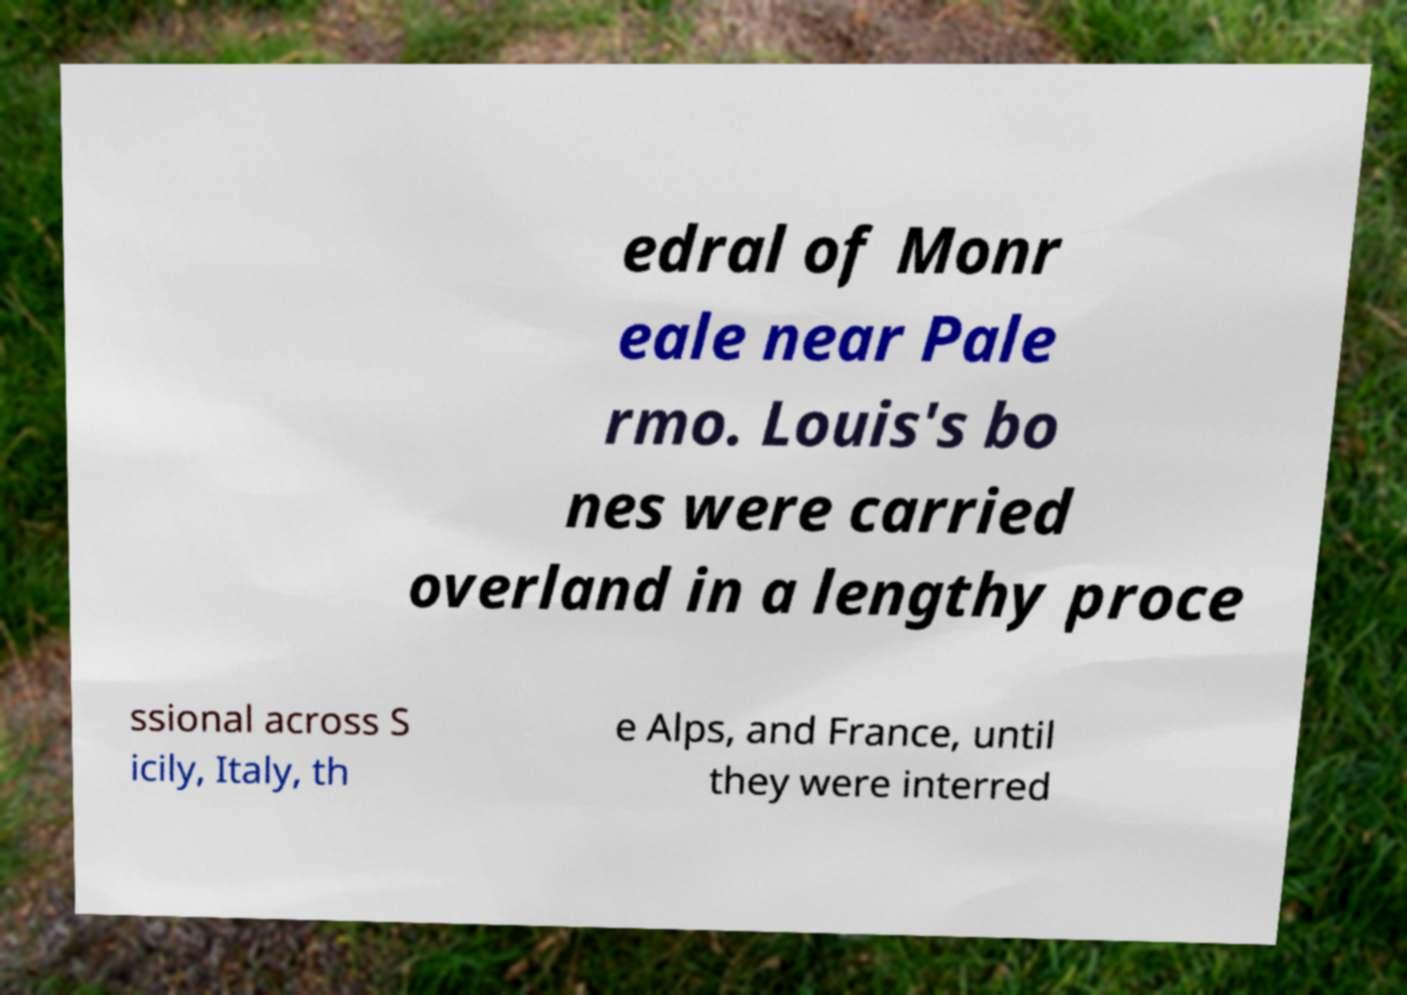Can you accurately transcribe the text from the provided image for me? edral of Monr eale near Pale rmo. Louis's bo nes were carried overland in a lengthy proce ssional across S icily, Italy, th e Alps, and France, until they were interred 